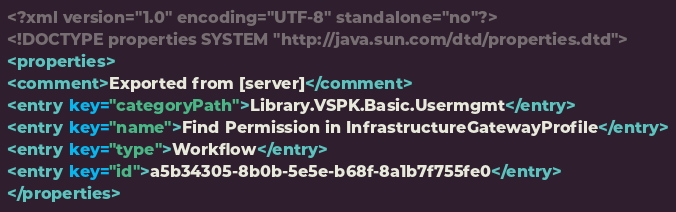<code> <loc_0><loc_0><loc_500><loc_500><_XML_><?xml version="1.0" encoding="UTF-8" standalone="no"?>
<!DOCTYPE properties SYSTEM "http://java.sun.com/dtd/properties.dtd">
<properties>
<comment>Exported from [server]</comment>
<entry key="categoryPath">Library.VSPK.Basic.Usermgmt</entry>
<entry key="name">Find Permission in InfrastructureGatewayProfile</entry>
<entry key="type">Workflow</entry>
<entry key="id">a5b34305-8b0b-5e5e-b68f-8a1b7f755fe0</entry>
</properties></code> 